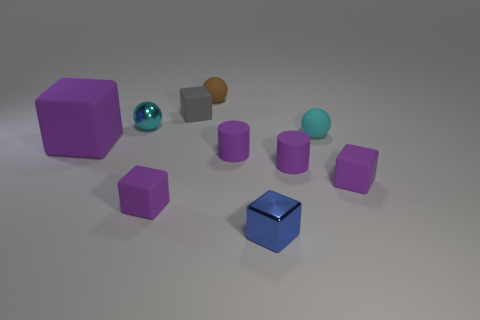What textures do the objects have and what time of day does the lighting suggest? The objects appear to have a rubber-like texture, except for the small blue-tinted cube which has a reflective, metallic texture and the teal sphere which has a glossy, reflective surface. The diffuse lighting in the scene doesn't strongly suggest a particular time of day, but it hints at an indoor setting, likely illuminated by artificial lighting due to the lack of shadows and soft light. 